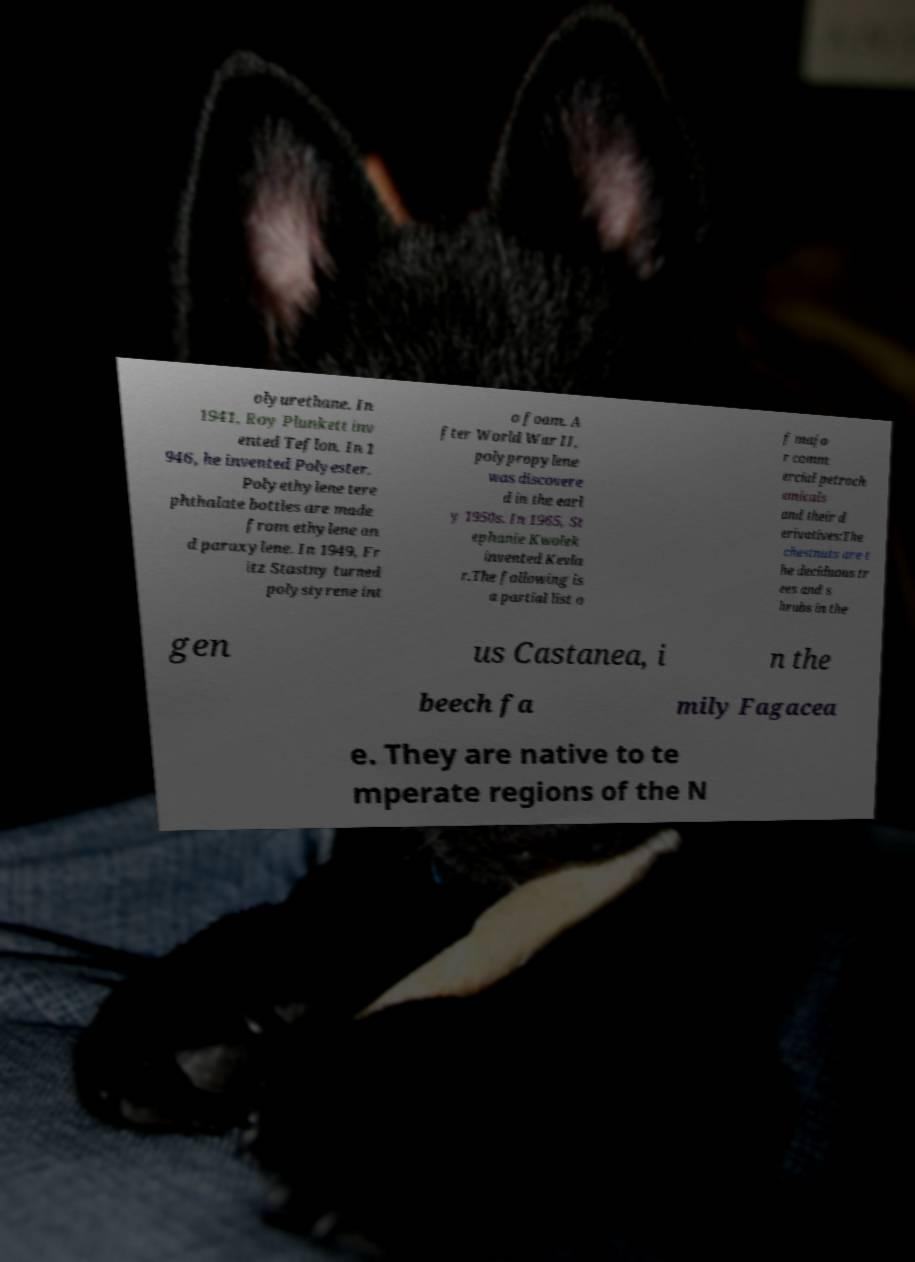Can you accurately transcribe the text from the provided image for me? olyurethane. In 1941, Roy Plunkett inv ented Teflon. In 1 946, he invented Polyester. Polyethylene tere phthalate bottles are made from ethylene an d paraxylene. In 1949, Fr itz Stastny turned polystyrene int o foam. A fter World War II, polypropylene was discovere d in the earl y 1950s. In 1965, St ephanie Kwolek invented Kevla r.The following is a partial list o f majo r comm ercial petroch emicals and their d erivatives:The chestnuts are t he deciduous tr ees and s hrubs in the gen us Castanea, i n the beech fa mily Fagacea e. They are native to te mperate regions of the N 